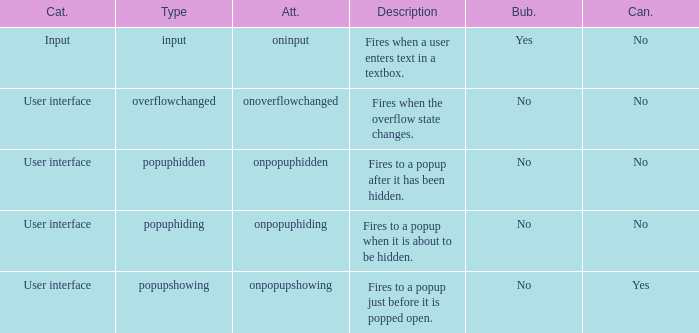What's the type with description being fires when the overflow state changes. Overflowchanged. 